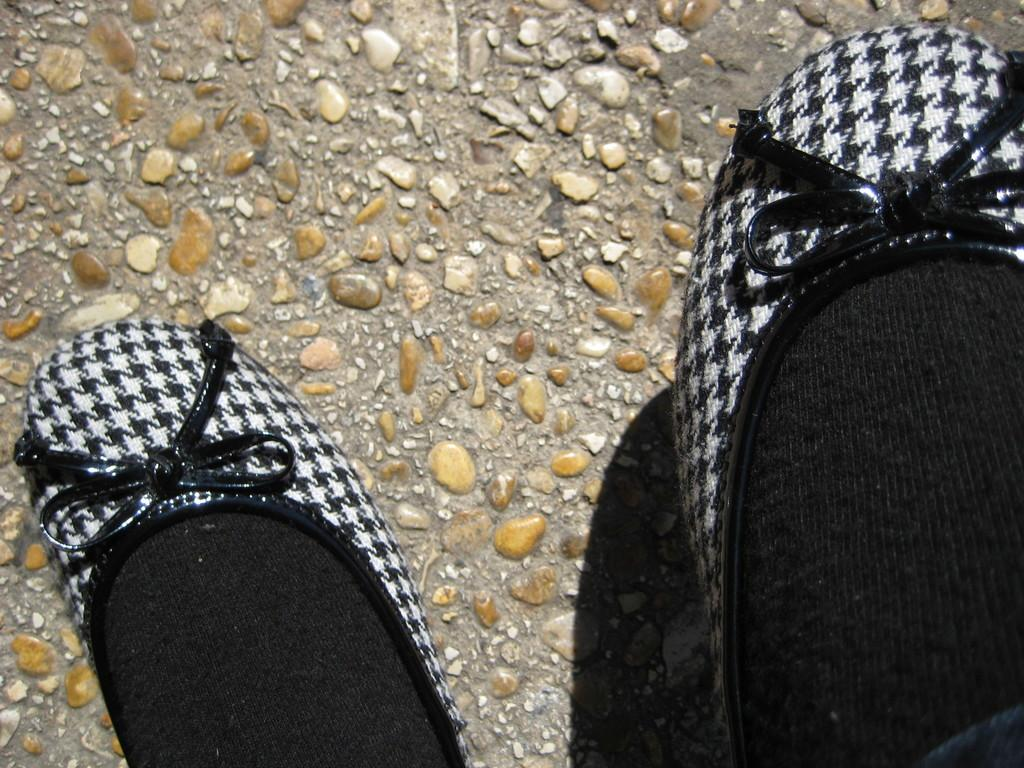Who or what is present in the image? There is a person in the image. What type of footwear is the person wearing? The person is wearing shoes. Are there any additional items of clothing visible? Yes, the person is also wearing socks. What can be seen in the background of the image? There are stones in the background of the image. What type of slave is depicted in the image? There is no slave depicted in the image; it features a person wearing shoes and socks. Can you tell me how many trains are visible in the image? There are no trains present in the image. 